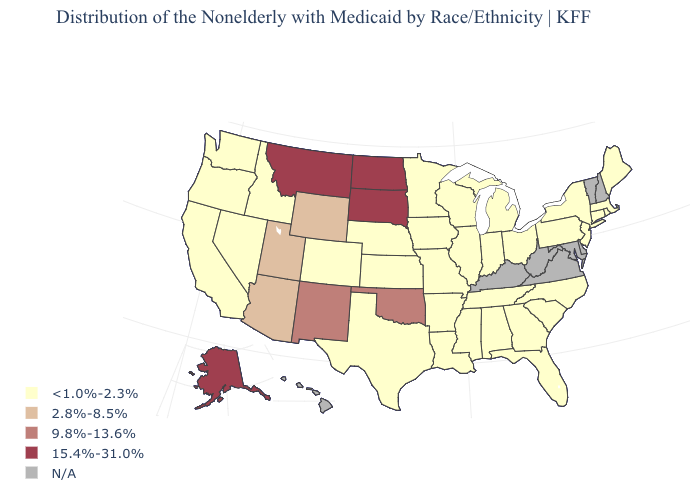Does Louisiana have the lowest value in the USA?
Short answer required. Yes. Name the states that have a value in the range N/A?
Concise answer only. Delaware, Hawaii, Kentucky, Maryland, New Hampshire, Vermont, Virginia, West Virginia. Is the legend a continuous bar?
Give a very brief answer. No. Which states have the lowest value in the Northeast?
Concise answer only. Connecticut, Maine, Massachusetts, New Jersey, New York, Pennsylvania, Rhode Island. What is the highest value in states that border Washington?
Be succinct. <1.0%-2.3%. What is the value of Illinois?
Concise answer only. <1.0%-2.3%. Name the states that have a value in the range 15.4%-31.0%?
Write a very short answer. Alaska, Montana, North Dakota, South Dakota. Which states have the lowest value in the West?
Be succinct. California, Colorado, Idaho, Nevada, Oregon, Washington. Name the states that have a value in the range 15.4%-31.0%?
Concise answer only. Alaska, Montana, North Dakota, South Dakota. What is the lowest value in states that border North Dakota?
Concise answer only. <1.0%-2.3%. How many symbols are there in the legend?
Be succinct. 5. What is the highest value in the USA?
Keep it brief. 15.4%-31.0%. 